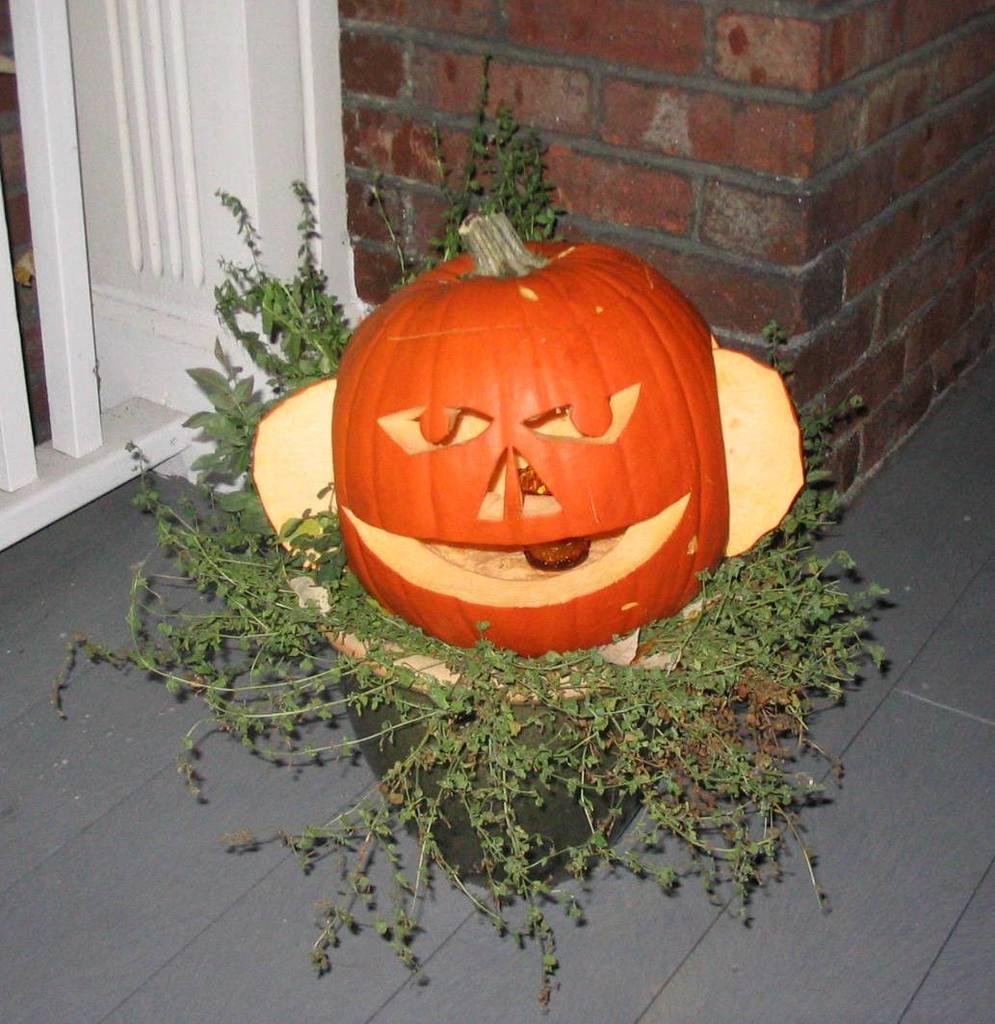Please provide a concise description of this image. In this picture I can see a fruit placed on the potted plant, behind there is a brick wall. 